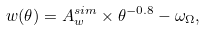<formula> <loc_0><loc_0><loc_500><loc_500>w ( \theta ) = A ^ { s i m } _ { w } \times \theta ^ { - 0 . 8 } - \omega _ { \Omega } ,</formula> 